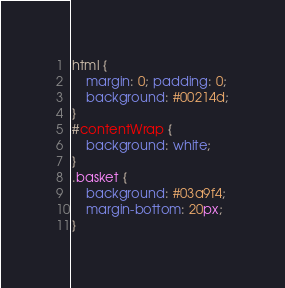Convert code to text. <code><loc_0><loc_0><loc_500><loc_500><_CSS_>html {
    margin: 0; padding: 0;
    background: #00214d;
}
#contentWrap {
    background: white;
}
.basket {
    background: #03a9f4;
    margin-bottom: 20px;
}</code> 